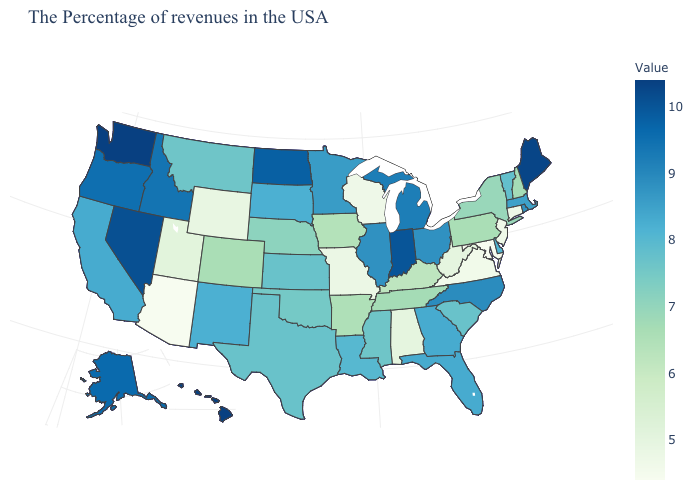Which states have the lowest value in the Northeast?
Be succinct. Connecticut, New Jersey. Does Rhode Island have the highest value in the Northeast?
Be succinct. No. Among the states that border Florida , which have the lowest value?
Write a very short answer. Alabama. Does New Jersey have the lowest value in the USA?
Short answer required. No. Does Hawaii have the highest value in the USA?
Keep it brief. Yes. Which states have the lowest value in the USA?
Short answer required. Maryland, Arizona. 